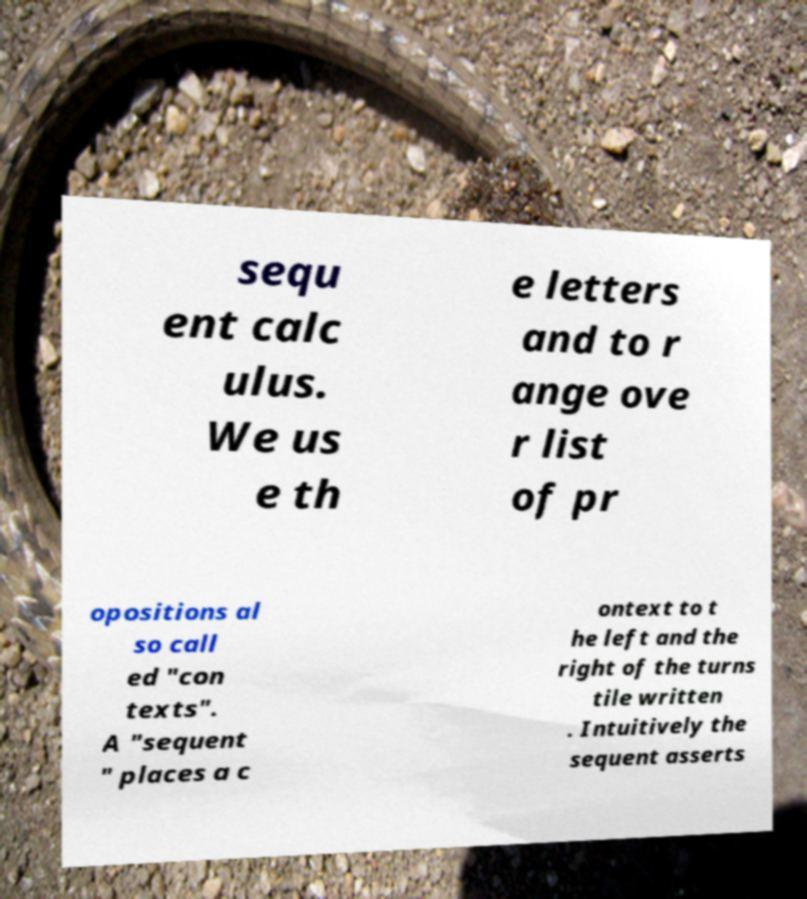Could you extract and type out the text from this image? sequ ent calc ulus. We us e th e letters and to r ange ove r list of pr opositions al so call ed "con texts". A "sequent " places a c ontext to t he left and the right of the turns tile written . Intuitively the sequent asserts 